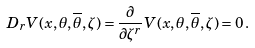<formula> <loc_0><loc_0><loc_500><loc_500>D _ { r } V ( x , \theta , { \overline { \theta } } , \zeta ) = \frac { \partial } { \partial \zeta ^ { r } } V ( x , \theta , { \overline { \theta } } , \zeta ) = 0 \, .</formula> 